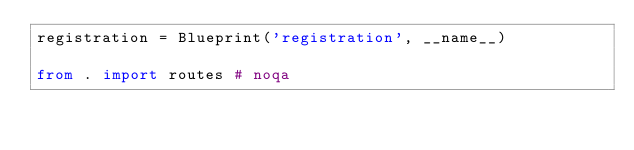Convert code to text. <code><loc_0><loc_0><loc_500><loc_500><_Python_>registration = Blueprint('registration', __name__)

from . import routes # noqa
</code> 